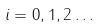<formula> <loc_0><loc_0><loc_500><loc_500>i = 0 , 1 , 2 \dots</formula> 